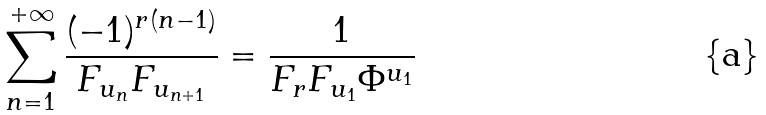<formula> <loc_0><loc_0><loc_500><loc_500>\sum _ { n = 1 } ^ { + \infty } \frac { ( - 1 ) ^ { r ( n - 1 ) } } { F _ { u _ { n } } F _ { u _ { n + 1 } } } = \frac { 1 } { F _ { r } F _ { u _ { 1 } } \Phi ^ { u _ { 1 } } }</formula> 